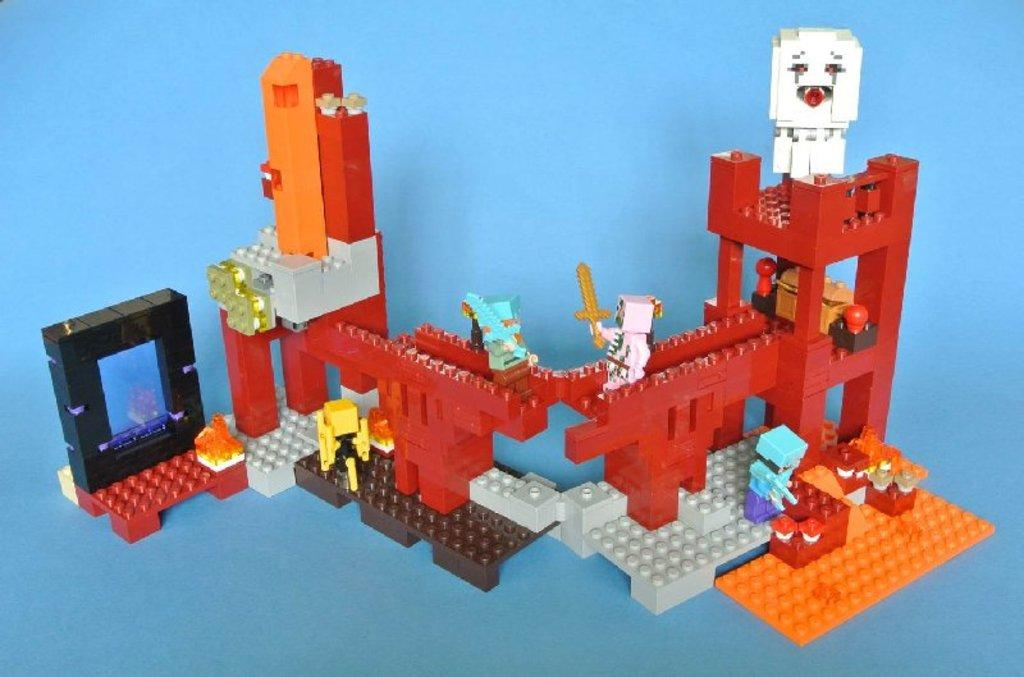What is the main subject of the image? The main subject of the image is a lego structure. Can you describe the colors of the lego structure? The lego structure has red, orange, white, blue, and black colors. What color is the background of the image? The background of the image is blue. What type of teaching is happening in the image? There is no teaching activity present in the image; it features a lego structure. How many mice can be seen playing with the lego structure in the image? There are no mice present in the image; it features a lego structure. 